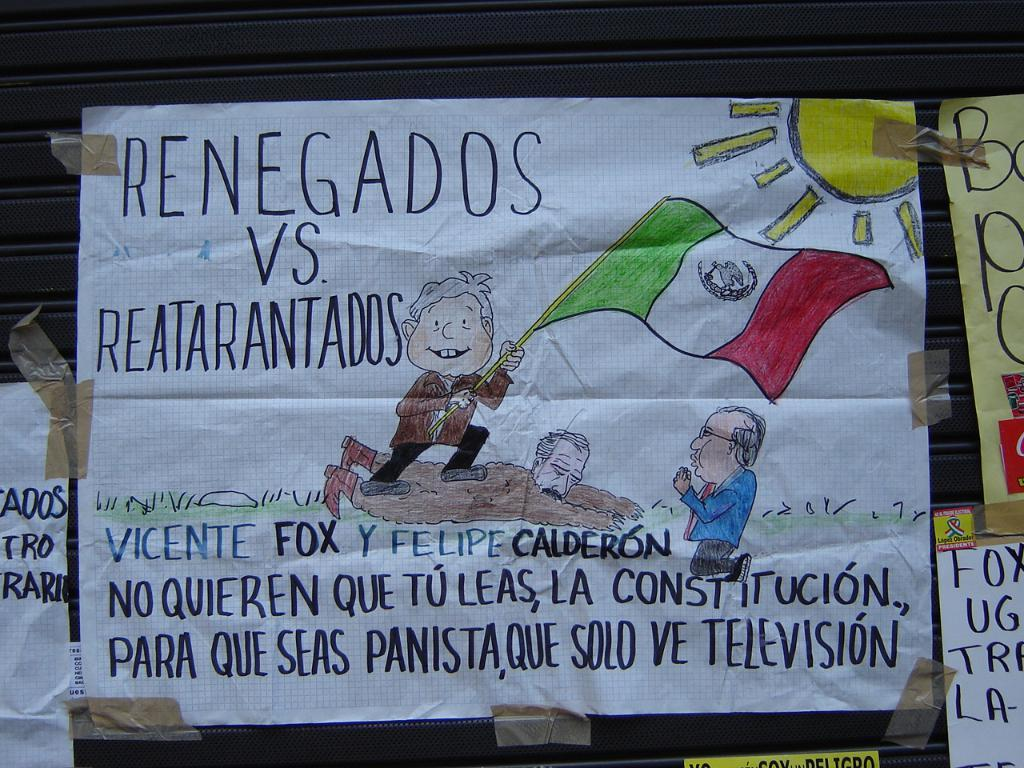<image>
Provide a brief description of the given image. A childs drawing of a man waving a flag has the text renegados on the top left side. 